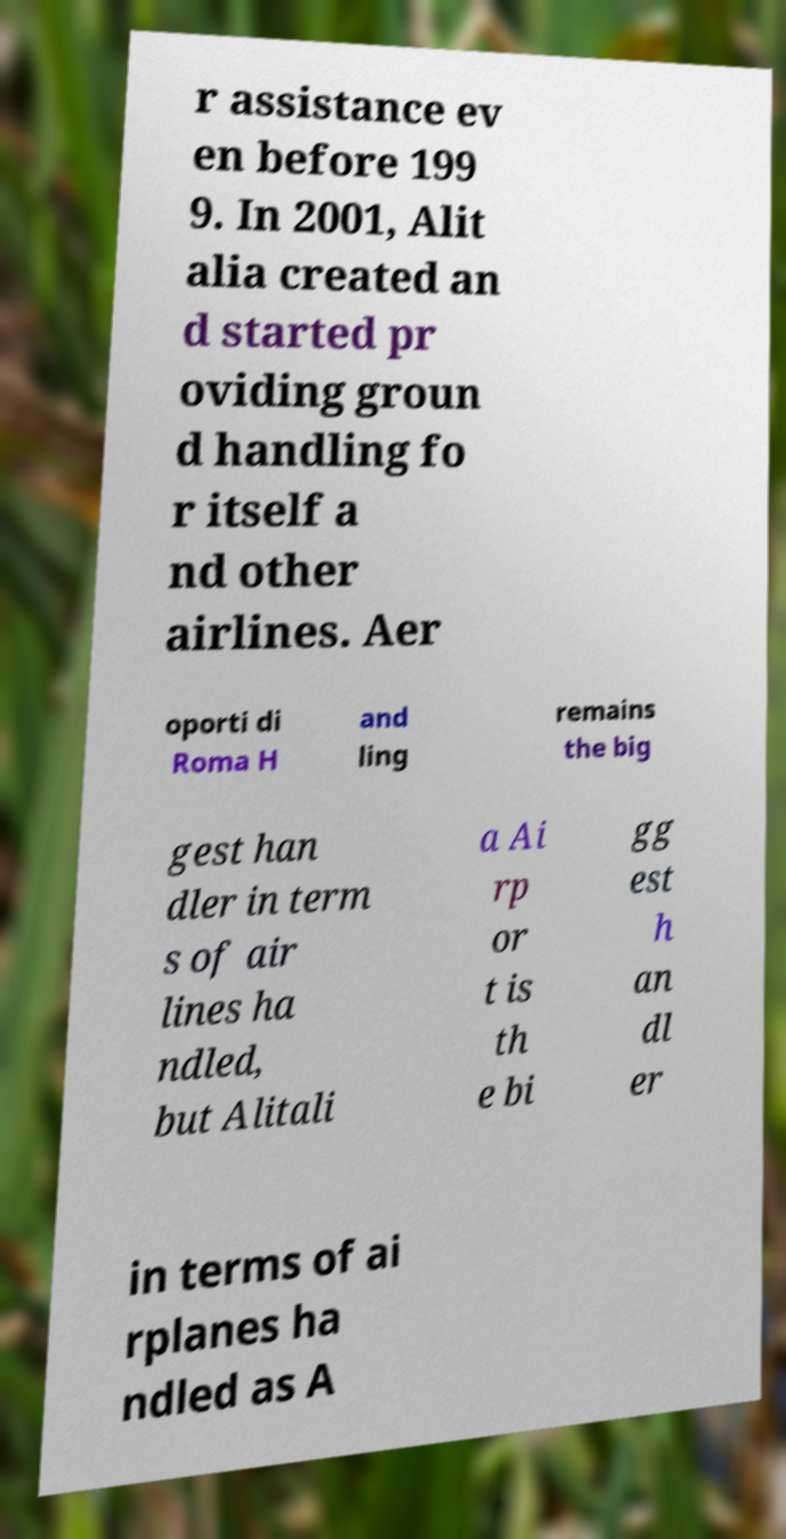Could you assist in decoding the text presented in this image and type it out clearly? r assistance ev en before 199 9. In 2001, Alit alia created an d started pr oviding groun d handling fo r itself a nd other airlines. Aer oporti di Roma H and ling remains the big gest han dler in term s of air lines ha ndled, but Alitali a Ai rp or t is th e bi gg est h an dl er in terms of ai rplanes ha ndled as A 